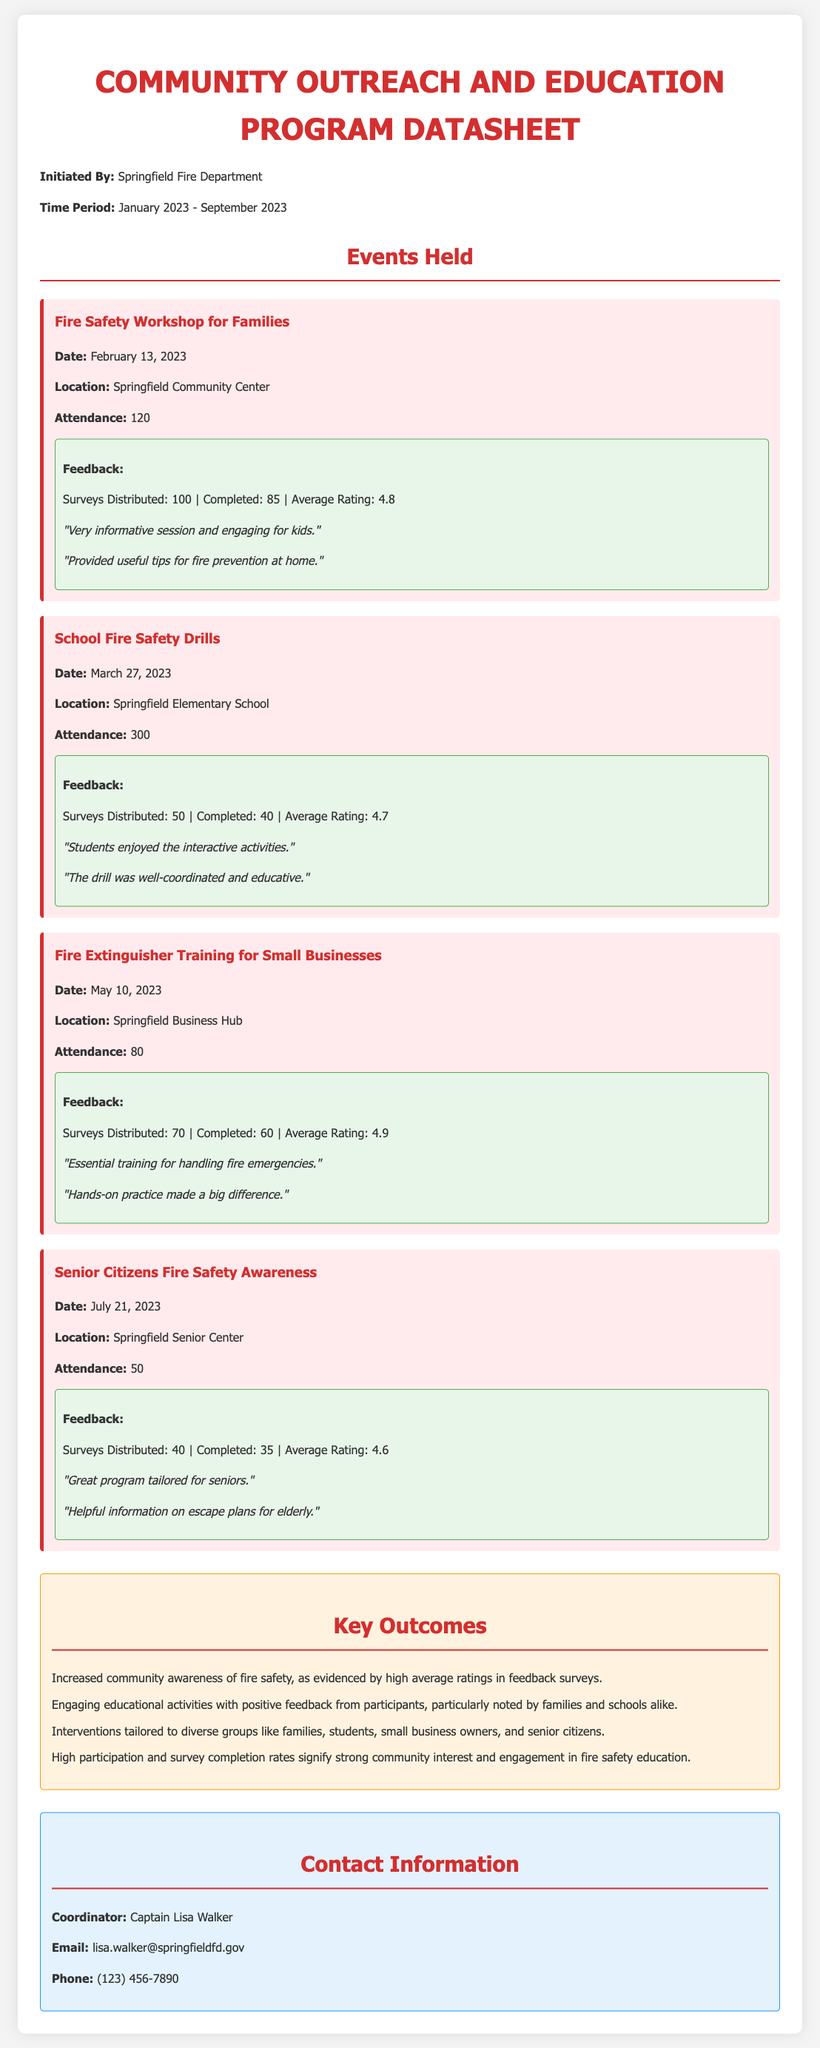What is the title of the datasheet? The title is clearly stated at the beginning of the document.
Answer: Community Outreach and Education Program Datasheet Who initiated the program? The initiating organization is mentioned in the introductory section of the document.
Answer: Springfield Fire Department What date was the Fire Safety Workshop for Families held? The specific date of this event is provided under the event details.
Answer: February 13, 2023 How many attendees were there at the School Fire Safety Drills? The attendance number is listed in the event section for this drill.
Answer: 300 What was the average rating for the Fire Extinguisher Training for Small Businesses? The average rating is included in the feedback section for this event.
Answer: 4.9 What is the date for the Senior Citizens Fire Safety Awareness event? The date for this specific event is detailed in the event information.
Answer: July 21, 2023 What is the main outcome regarding community awareness based on the feedback? This outcome is summarized in the key outcomes section of the document.
Answer: Increased community awareness of fire safety Which group had the least attendance at their event? Comparisons can be made from the attendance numbers listed for different events.
Answer: Senior Citizens Fire Safety Awareness What type of activities were reported positively by participants? Positive engagement activities are highlighted within the document summary.
Answer: Engaging educational activities 